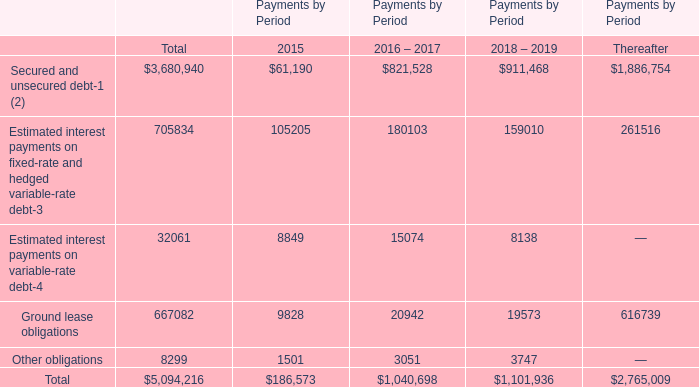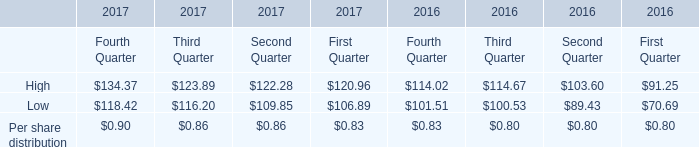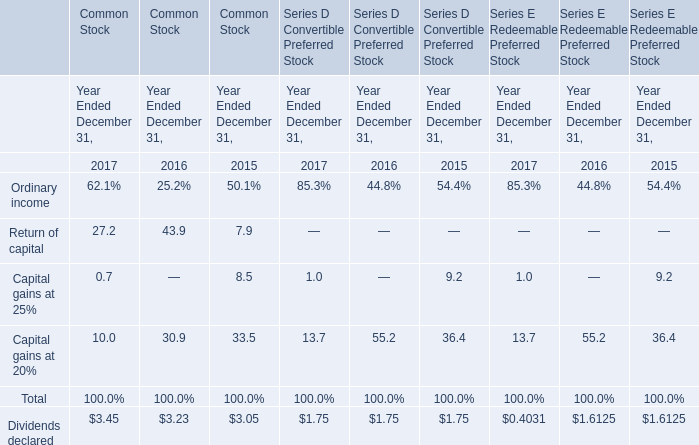In the year with lowest amount of Per share distribution, what's the increasing rate of Hjgh? 
Computations: (((((134.37 + 123.89) + 122.28) + 120.96) - ((((120.96 + 114.02) + 114.67) + 103.60) + 91.25)) / ((((120.96 + 114.02) + 114.67) + 103.60) + 91.25))
Answer: -0.07897. 